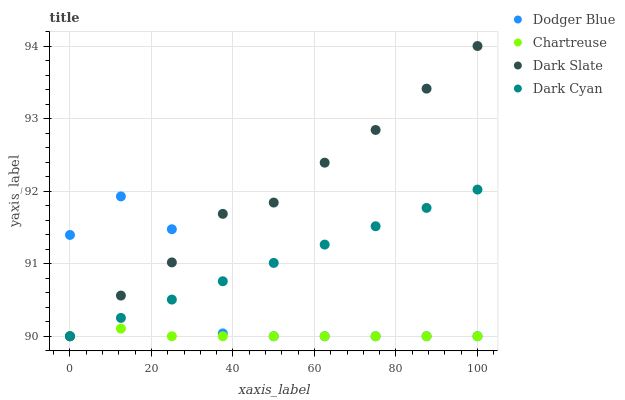Does Chartreuse have the minimum area under the curve?
Answer yes or no. Yes. Does Dark Slate have the maximum area under the curve?
Answer yes or no. Yes. Does Dark Slate have the minimum area under the curve?
Answer yes or no. No. Does Chartreuse have the maximum area under the curve?
Answer yes or no. No. Is Dark Cyan the smoothest?
Answer yes or no. Yes. Is Dodger Blue the roughest?
Answer yes or no. Yes. Is Dark Slate the smoothest?
Answer yes or no. No. Is Dark Slate the roughest?
Answer yes or no. No. Does Dark Cyan have the lowest value?
Answer yes or no. Yes. Does Dark Slate have the highest value?
Answer yes or no. Yes. Does Chartreuse have the highest value?
Answer yes or no. No. Does Dark Slate intersect Dark Cyan?
Answer yes or no. Yes. Is Dark Slate less than Dark Cyan?
Answer yes or no. No. Is Dark Slate greater than Dark Cyan?
Answer yes or no. No. 